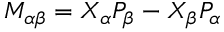Convert formula to latex. <formula><loc_0><loc_0><loc_500><loc_500>M _ { \alpha \beta } = X _ { \alpha } P _ { \beta } - X _ { \beta } P _ { \alpha }</formula> 